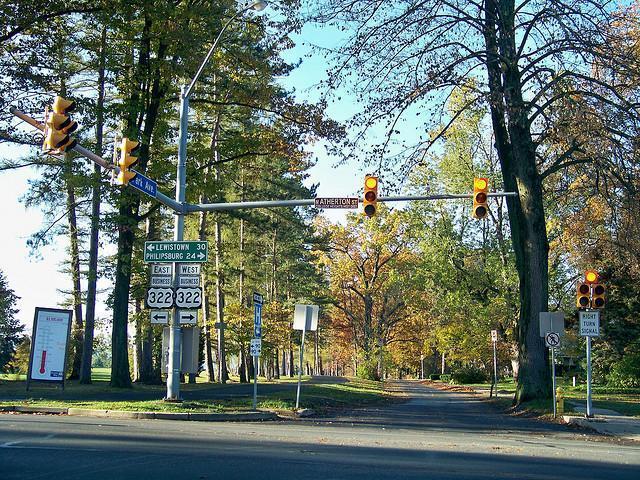How many signal lights are in the picture?
Give a very brief answer. 5. 